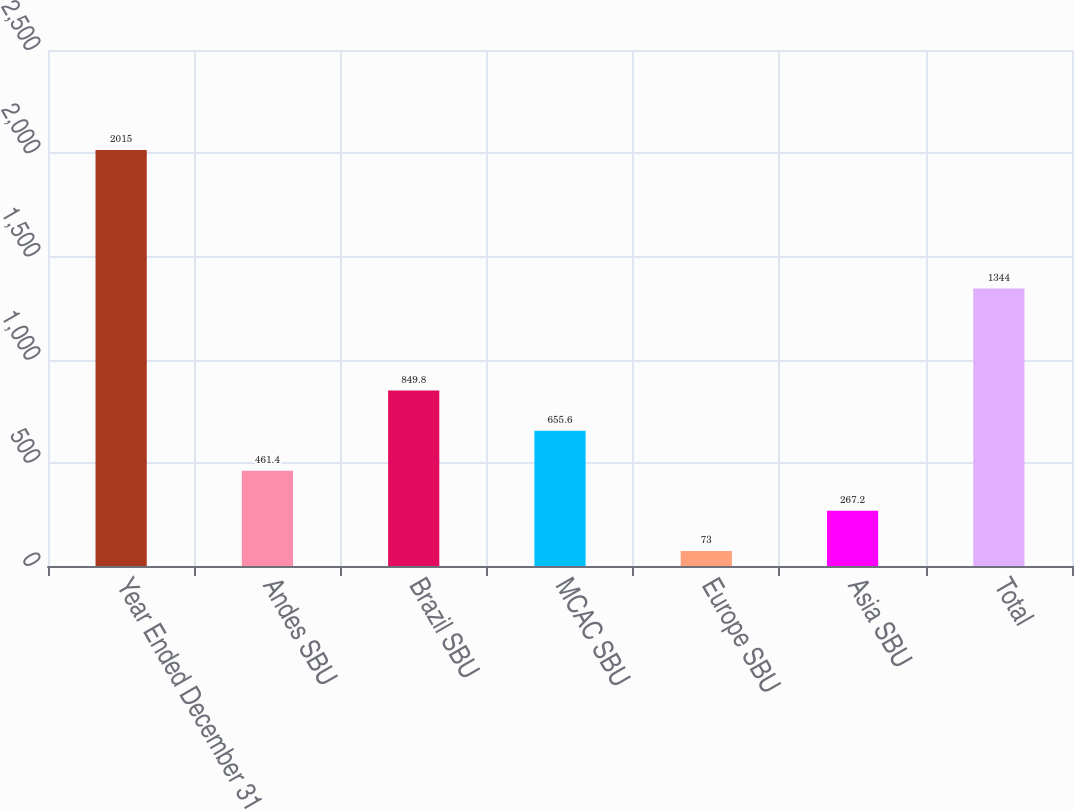Convert chart. <chart><loc_0><loc_0><loc_500><loc_500><bar_chart><fcel>Year Ended December 31<fcel>Andes SBU<fcel>Brazil SBU<fcel>MCAC SBU<fcel>Europe SBU<fcel>Asia SBU<fcel>Total<nl><fcel>2015<fcel>461.4<fcel>849.8<fcel>655.6<fcel>73<fcel>267.2<fcel>1344<nl></chart> 